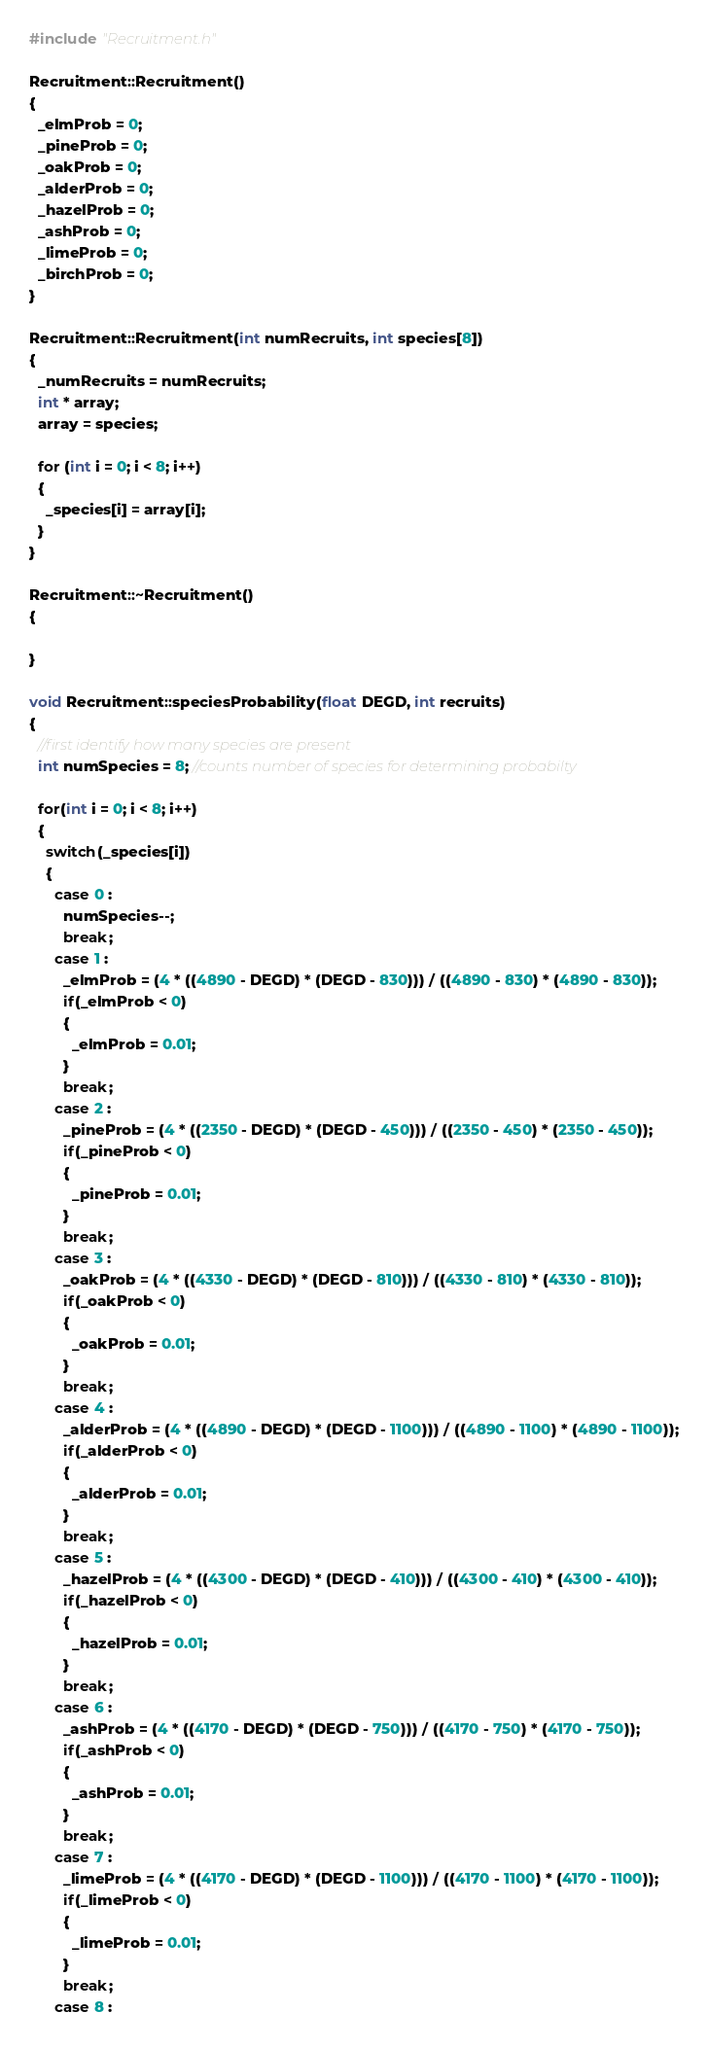Convert code to text. <code><loc_0><loc_0><loc_500><loc_500><_C++_>#include "Recruitment.h"

Recruitment::Recruitment()
{
  _elmProb = 0;
  _pineProb = 0;
  _oakProb = 0;
  _alderProb = 0;
  _hazelProb = 0;
  _ashProb = 0;
  _limeProb = 0;
  _birchProb = 0;
}

Recruitment::Recruitment(int numRecruits, int species[8])
{
  _numRecruits = numRecruits;
  int * array;
  array = species;

  for (int i = 0; i < 8; i++)
  {
    _species[i] = array[i];
  }
}

Recruitment::~Recruitment()
{

}

void Recruitment::speciesProbability(float DEGD, int recruits)
{
  //first identify how many species are present
  int numSpecies = 8; //counts number of species for determining probabilty

  for(int i = 0; i < 8; i++)
  {
    switch(_species[i])
    {
      case 0 :
        numSpecies--;
        break;
      case 1 :
        _elmProb = (4 * ((4890 - DEGD) * (DEGD - 830))) / ((4890 - 830) * (4890 - 830));
        if(_elmProb < 0)
        {
          _elmProb = 0.01;
        }
        break;
      case 2 :
        _pineProb = (4 * ((2350 - DEGD) * (DEGD - 450))) / ((2350 - 450) * (2350 - 450));
        if(_pineProb < 0)
        {
          _pineProb = 0.01;
        }
        break;
      case 3 :
        _oakProb = (4 * ((4330 - DEGD) * (DEGD - 810))) / ((4330 - 810) * (4330 - 810));
        if(_oakProb < 0)
        {
          _oakProb = 0.01;
        }
        break;
      case 4 :
        _alderProb = (4 * ((4890 - DEGD) * (DEGD - 1100))) / ((4890 - 1100) * (4890 - 1100));
        if(_alderProb < 0)
        {
          _alderProb = 0.01;
        }
        break;
      case 5 :
        _hazelProb = (4 * ((4300 - DEGD) * (DEGD - 410))) / ((4300 - 410) * (4300 - 410));
        if(_hazelProb < 0)
        {
          _hazelProb = 0.01;
        }
        break;
      case 6 :
        _ashProb = (4 * ((4170 - DEGD) * (DEGD - 750))) / ((4170 - 750) * (4170 - 750));
        if(_ashProb < 0)
        {
          _ashProb = 0.01;
        }
        break;
      case 7 :
        _limeProb = (4 * ((4170 - DEGD) * (DEGD - 1100))) / ((4170 - 1100) * (4170 - 1100));
        if(_limeProb < 0)
        {
          _limeProb = 0.01;
        }
        break;
      case 8 :</code> 